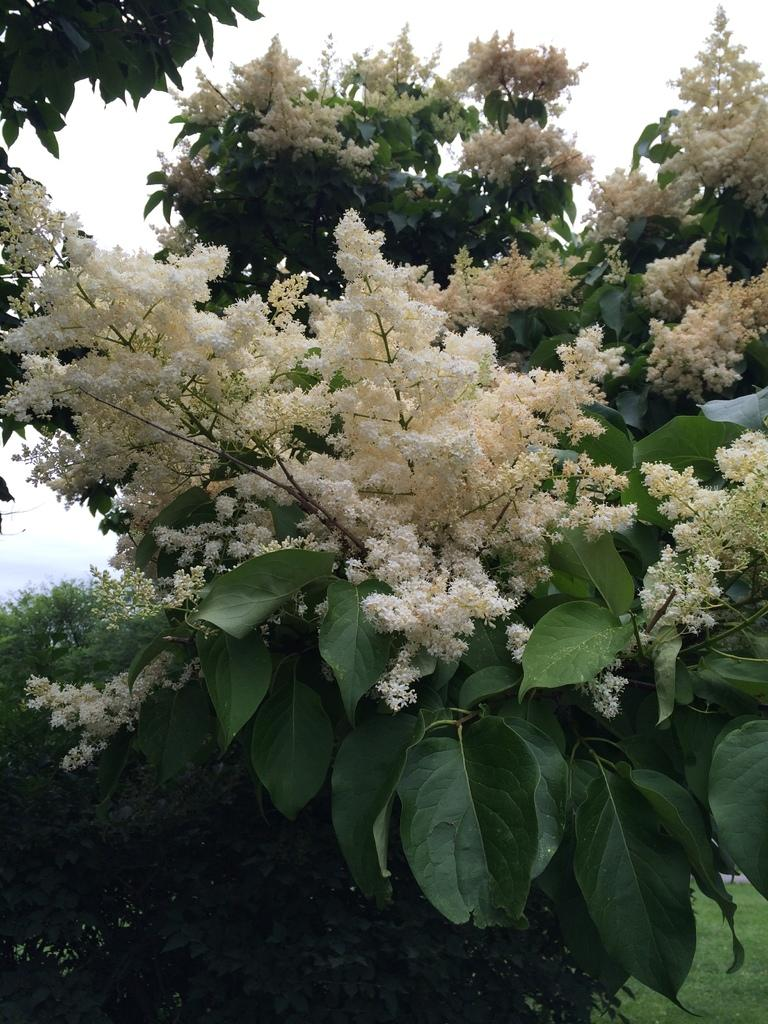What type of plant is present in the image? There is a tree with flowers in the image. What color are the flowers on the tree? The flowers are white. What type of vegetation is visible at the bottom right of the image? There is grass in the right bottom of the image. What is visible at the top of the image? The sky is visible at the top of the image. Can you touch the spoon in the image? There is no spoon present in the image, so it cannot be touched. 